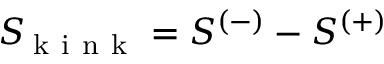Convert formula to latex. <formula><loc_0><loc_0><loc_500><loc_500>S _ { \, k i n k } = S ^ { ( - ) } - S ^ { ( + ) }</formula> 